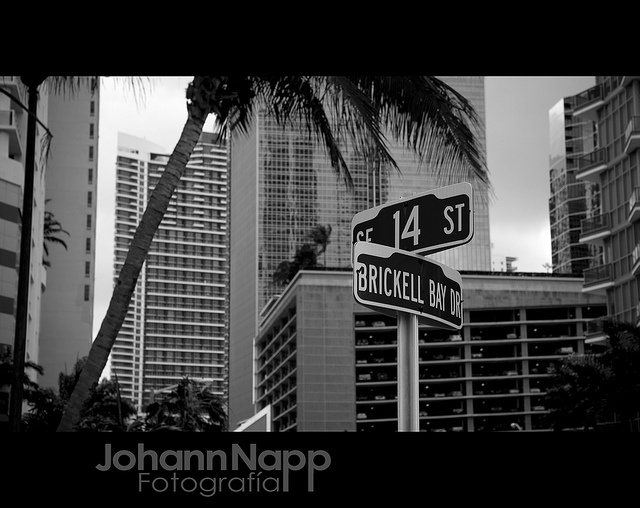Describe the objects in this image and their specific colors. I can see various objects in this image with different colors. 